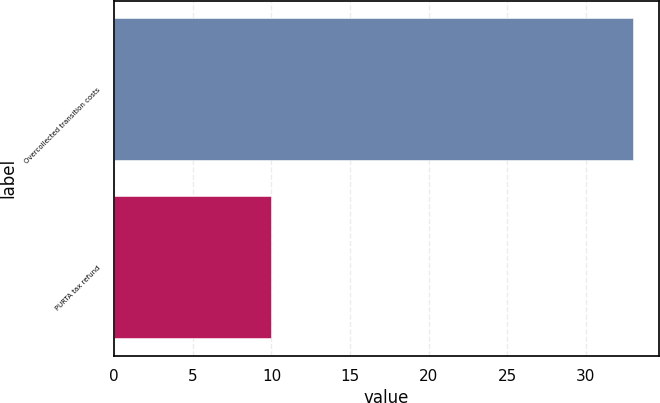Convert chart. <chart><loc_0><loc_0><loc_500><loc_500><bar_chart><fcel>Overcollected transition costs<fcel>PURTA tax refund<nl><fcel>33<fcel>10<nl></chart> 